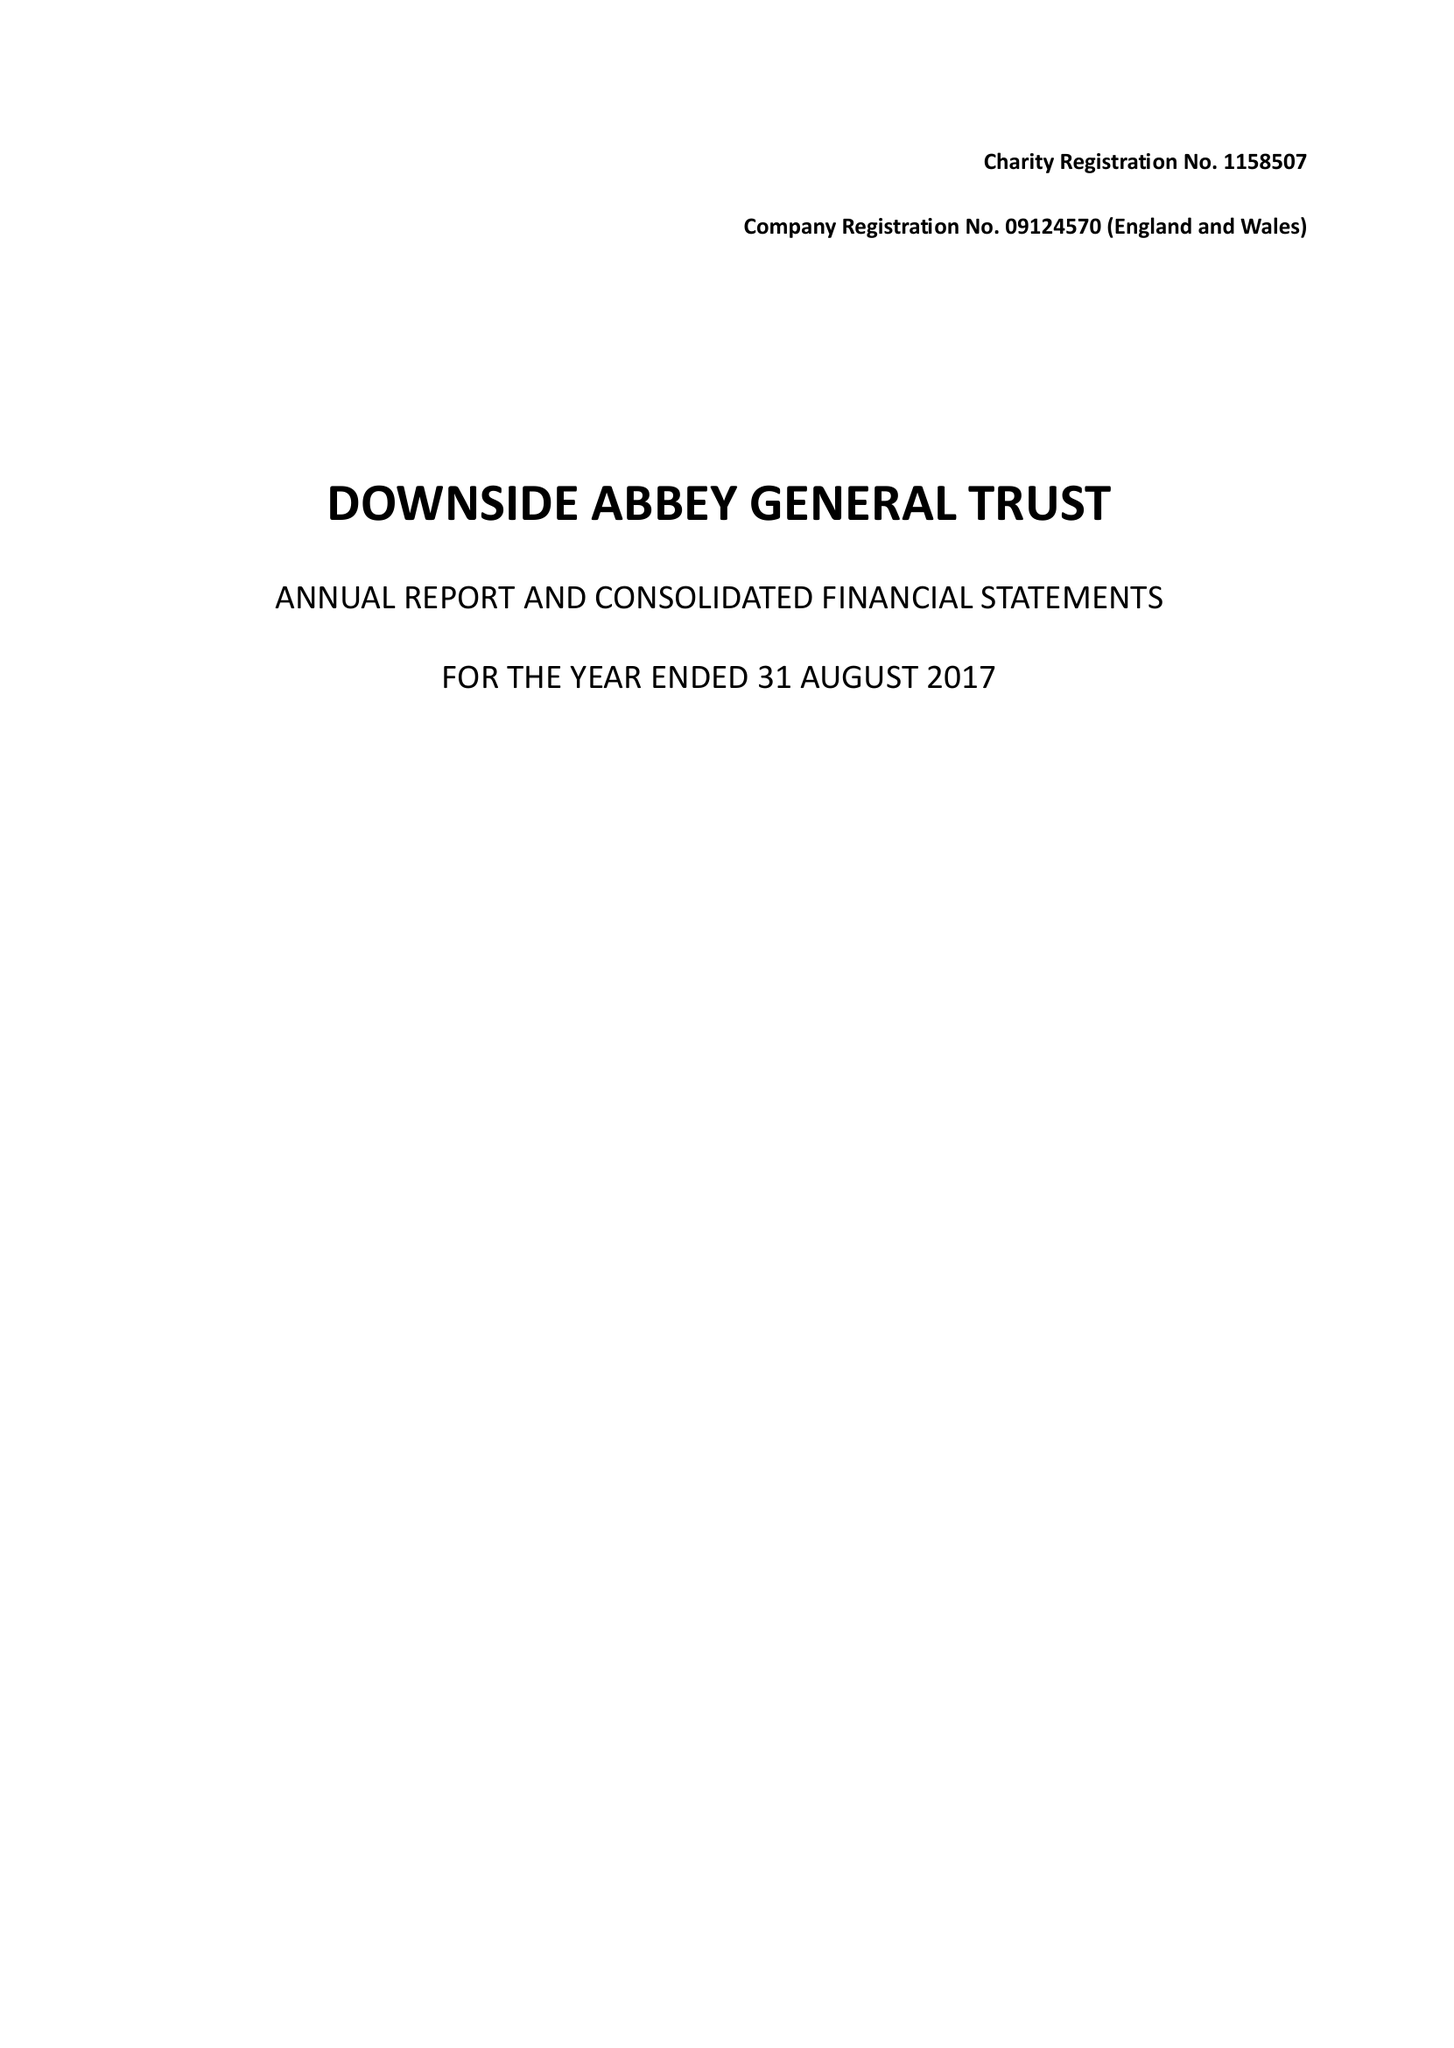What is the value for the address__postcode?
Answer the question using a single word or phrase. BA3 4RH 